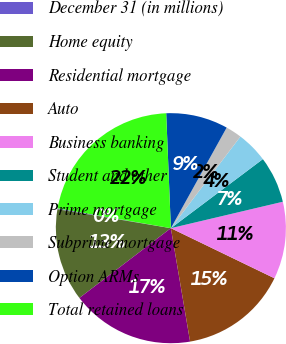Convert chart. <chart><loc_0><loc_0><loc_500><loc_500><pie_chart><fcel>December 31 (in millions)<fcel>Home equity<fcel>Residential mortgage<fcel>Auto<fcel>Business banking<fcel>Student and other<fcel>Prime mortgage<fcel>Subprime mortgage<fcel>Option ARMs<fcel>Total retained loans<nl><fcel>0.12%<fcel>13.01%<fcel>17.3%<fcel>15.16%<fcel>10.86%<fcel>6.56%<fcel>4.42%<fcel>2.27%<fcel>8.71%<fcel>21.6%<nl></chart> 